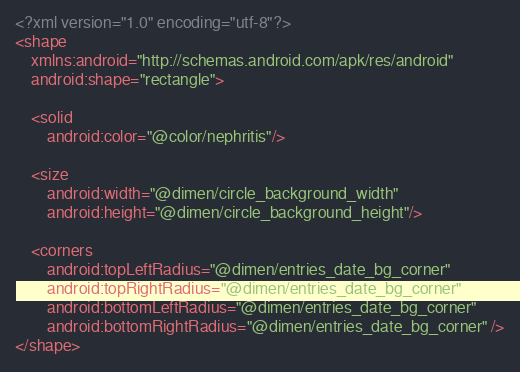<code> <loc_0><loc_0><loc_500><loc_500><_XML_><?xml version="1.0" encoding="utf-8"?>
<shape
    xmlns:android="http://schemas.android.com/apk/res/android"
    android:shape="rectangle">

    <solid
        android:color="@color/nephritis"/>

    <size
        android:width="@dimen/circle_background_width"
        android:height="@dimen/circle_background_height"/>

    <corners
        android:topLeftRadius="@dimen/entries_date_bg_corner"
        android:topRightRadius="@dimen/entries_date_bg_corner"
        android:bottomLeftRadius="@dimen/entries_date_bg_corner"
        android:bottomRightRadius="@dimen/entries_date_bg_corner" />
</shape></code> 